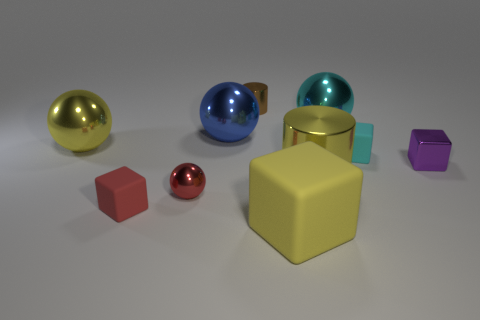Do the big cylinder and the big block have the same color?
Offer a very short reply. Yes. The red metal sphere has what size?
Make the answer very short. Small. What size is the purple metallic thing that is the same shape as the tiny red matte object?
Your answer should be compact. Small. There is a tiny metallic object that is in front of the large cylinder; what number of big spheres are to the right of it?
Offer a terse response. 2. Are the cylinder that is in front of the brown shiny object and the yellow thing in front of the small red sphere made of the same material?
Your response must be concise. No. How many large yellow things are the same shape as the small cyan object?
Your response must be concise. 1. What number of large blocks are the same color as the large cylinder?
Provide a succinct answer. 1. Do the small matte object right of the large cyan metallic thing and the small object behind the cyan ball have the same shape?
Keep it short and to the point. No. What number of cubes are on the right side of the big yellow shiny object in front of the large shiny ball that is on the left side of the red ball?
Give a very brief answer. 2. There is a thing that is to the right of the matte object that is behind the purple block that is on the right side of the small cyan block; what is its material?
Ensure brevity in your answer.  Metal. 